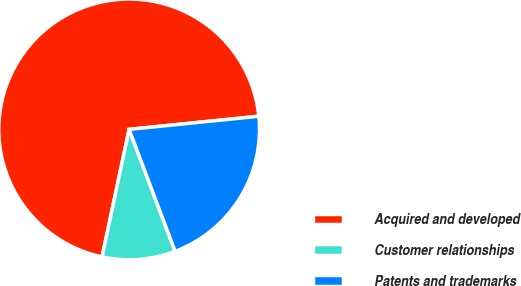<chart> <loc_0><loc_0><loc_500><loc_500><pie_chart><fcel>Acquired and developed<fcel>Customer relationships<fcel>Patents and trademarks<nl><fcel>70.06%<fcel>9.07%<fcel>20.87%<nl></chart> 